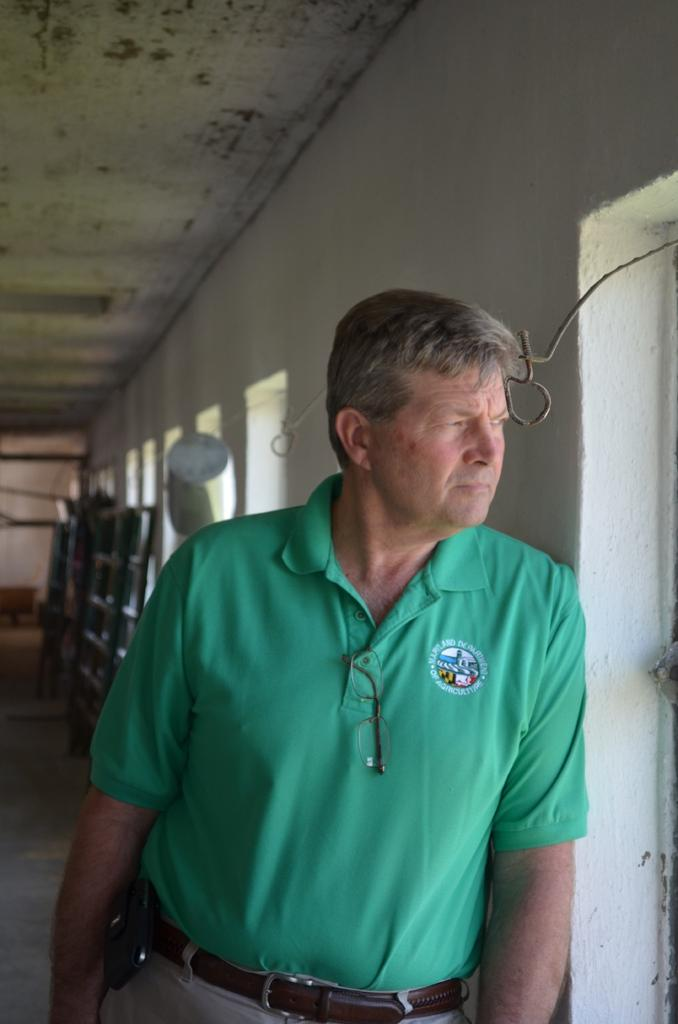Who is present in the image? There is a man in the image. What is the man wearing? The man is wearing a green T-shirt. What can be seen behind the man in the image? There is a white wall in the background of the image. What architectural features are visible in the image? There is a roof and a floor visible in the image. What is the man doing with his toes in the image? There is no indication of the man's toes in the image, as only his torso and the green T-shirt are visible. 